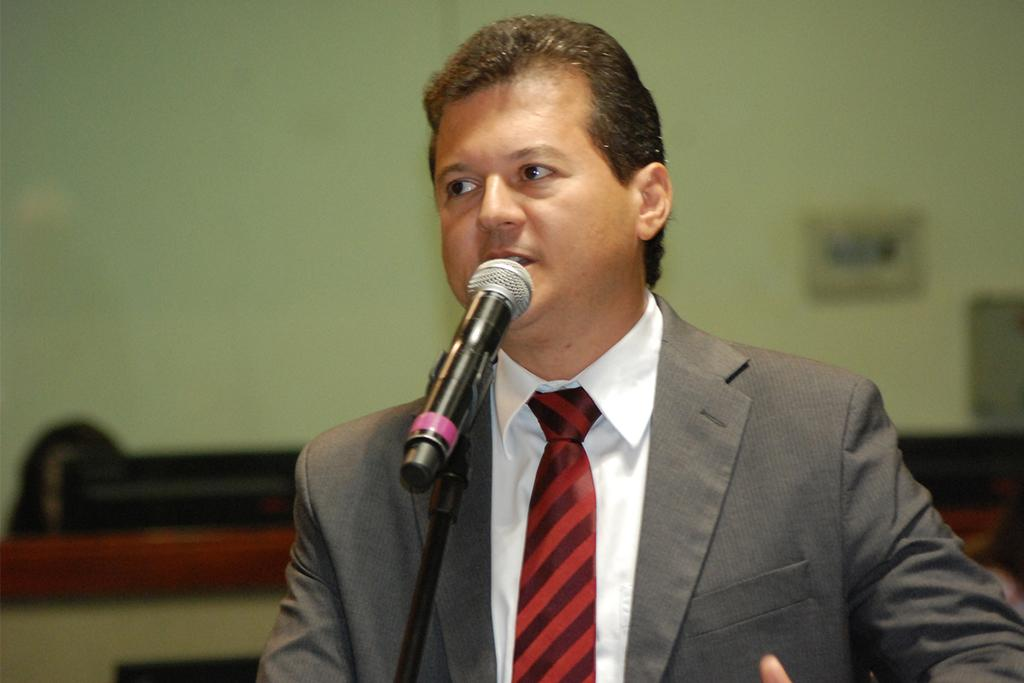What is happening in the image? There is a person in the image who is talking. What object is in front of the person? There is a microphone in front of the person. What can be seen behind the person? There is a wall visible in the image. How is the background of the image depicted? The background of the image is blurred. What type of credit does the person in the image have? There is no information about the person's credit in the image. Who is the porter in the image? There is no porter present in the image. 